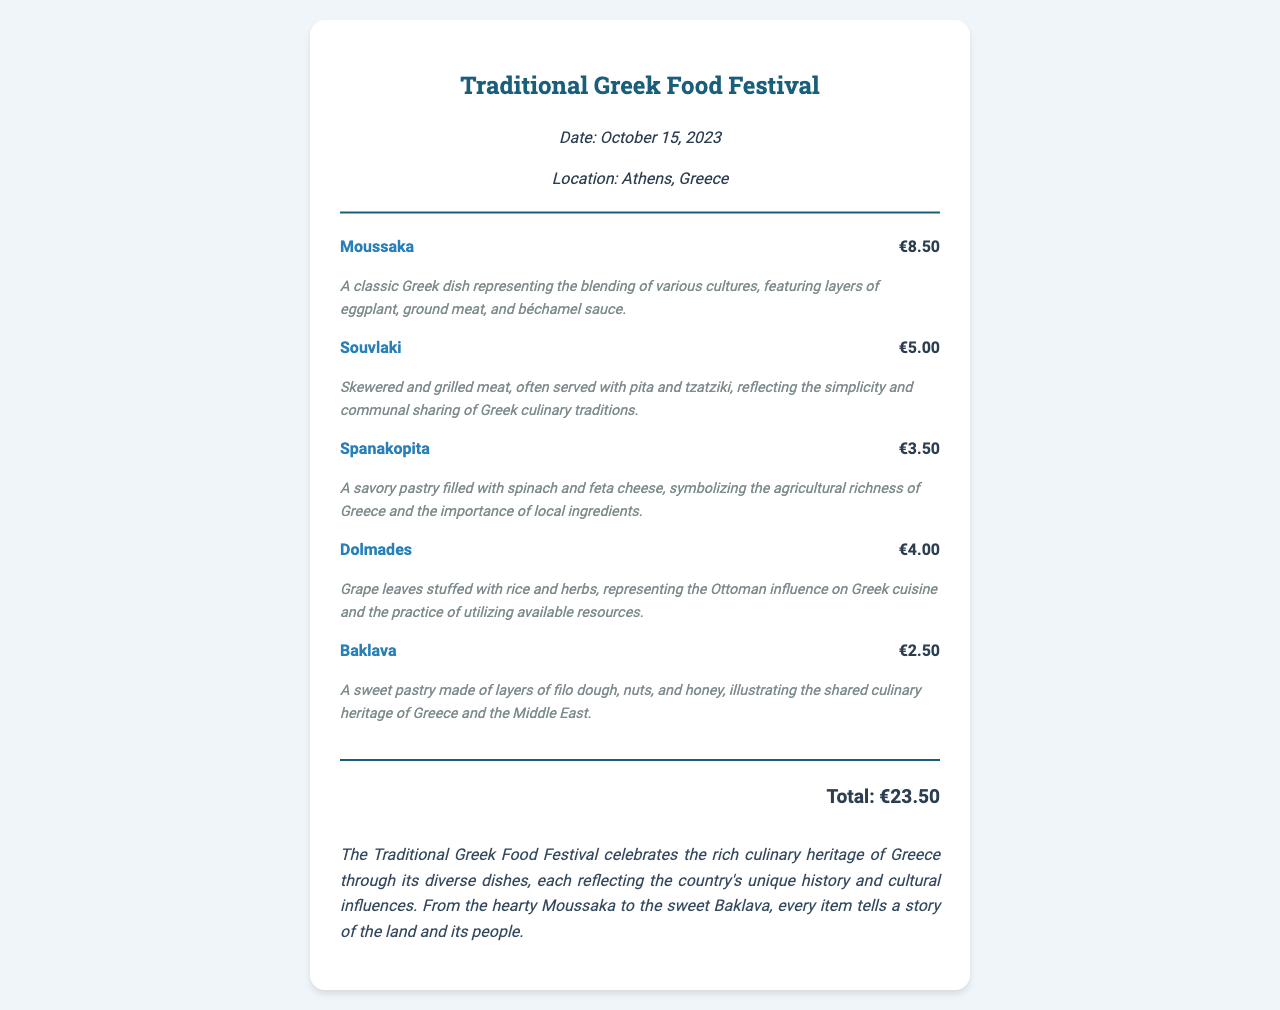What is the date of the festival? The date of the festival is prominently displayed within the document.
Answer: October 15, 2023 What is the location of the festival? The location is mentioned in the festival information section.
Answer: Athens, Greece How much does Moussaka cost? The price for Moussaka is clearly indicated next to the item's name.
Answer: €8.50 What is the total amount spent? The total is calculated and displayed at the bottom of the receipt.
Answer: €23.50 What type of dish is Spanakopita? The cultural significance section describes the item.
Answer: Savory pastry What influences are represented in Dolmades? The cultural significance explains the historical context.
Answer: Ottoman influence How many items were purchased? The items listed in the receipt provide a count of the different food items.
Answer: 5 What does Baklava illustrate about culinary heritage? The cultural significance section highlights its representation.
Answer: Shared culinary heritage What is the significance of Souvlaki in Greek tradition? The cultural significance section elaborates on its importance in communal sharing.
Answer: Simplicity and communal sharing 